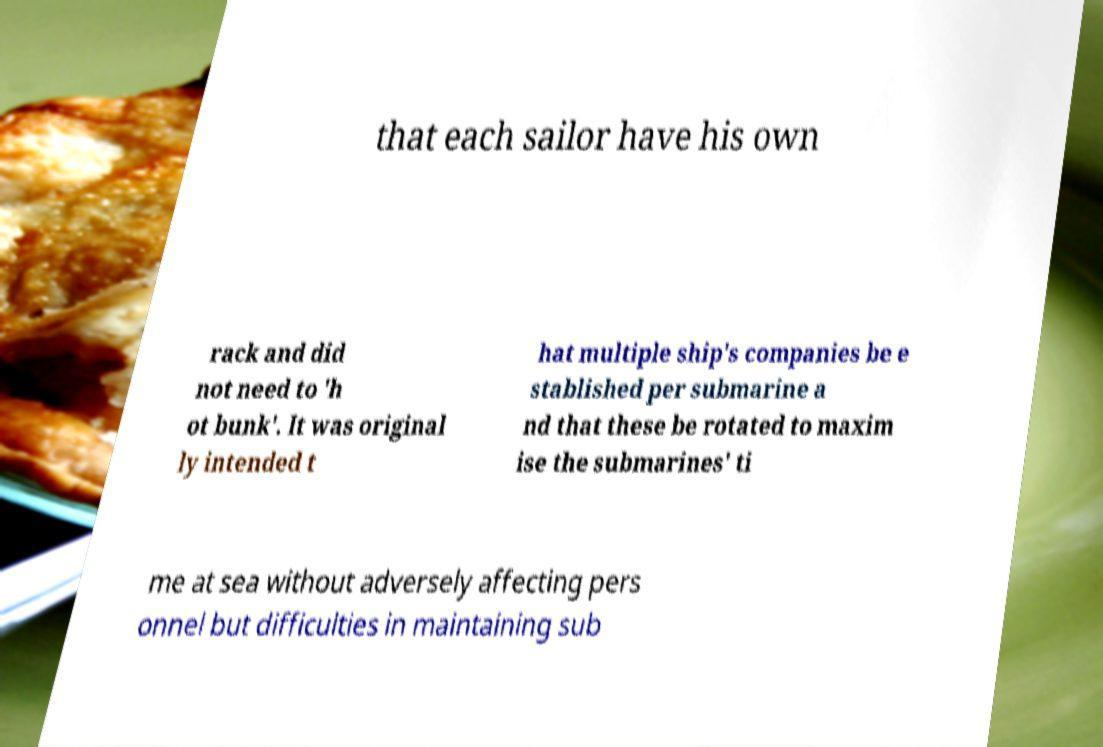I need the written content from this picture converted into text. Can you do that? that each sailor have his own rack and did not need to 'h ot bunk'. It was original ly intended t hat multiple ship's companies be e stablished per submarine a nd that these be rotated to maxim ise the submarines' ti me at sea without adversely affecting pers onnel but difficulties in maintaining sub 